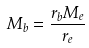<formula> <loc_0><loc_0><loc_500><loc_500>M _ { b } = \frac { r _ { b } M _ { e } } { r _ { e } }</formula> 